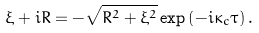<formula> <loc_0><loc_0><loc_500><loc_500>\xi + i R = - \sqrt { R ^ { 2 } + \xi ^ { 2 } } \exp \left ( - i \kappa _ { c } \tau \right ) .</formula> 